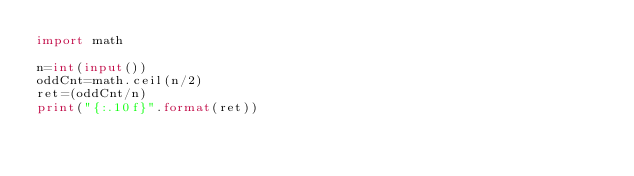<code> <loc_0><loc_0><loc_500><loc_500><_Python_>import math

n=int(input())
oddCnt=math.ceil(n/2)
ret=(oddCnt/n)
print("{:.10f}".format(ret))</code> 